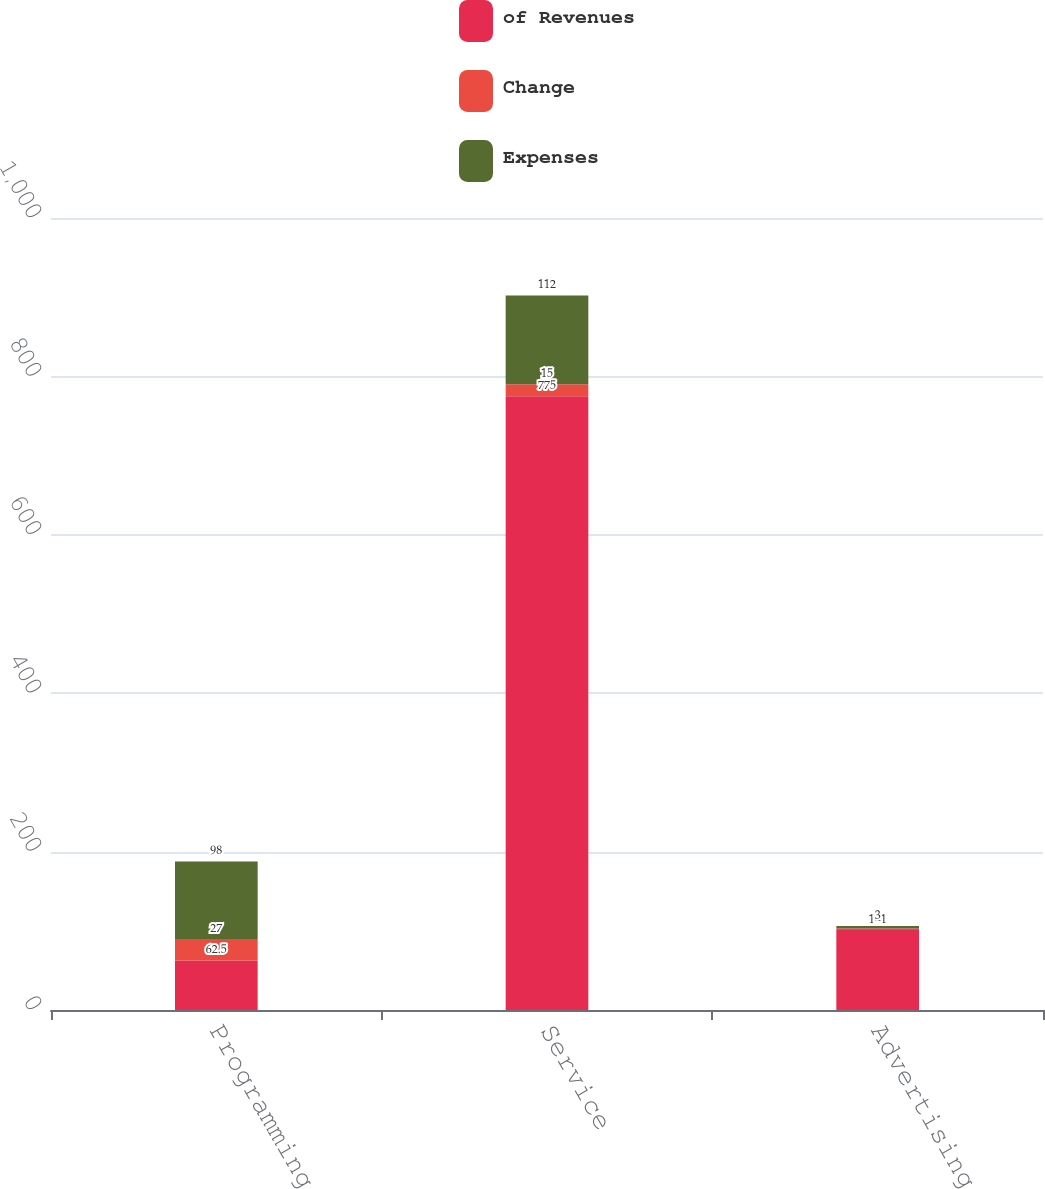Convert chart to OTSL. <chart><loc_0><loc_0><loc_500><loc_500><stacked_bar_chart><ecel><fcel>Programming<fcel>Service<fcel>Advertising sales<nl><fcel>of Revenues<fcel>62.5<fcel>775<fcel>101<nl><fcel>Change<fcel>27<fcel>15<fcel>2<nl><fcel>Expenses<fcel>98<fcel>112<fcel>3<nl></chart> 